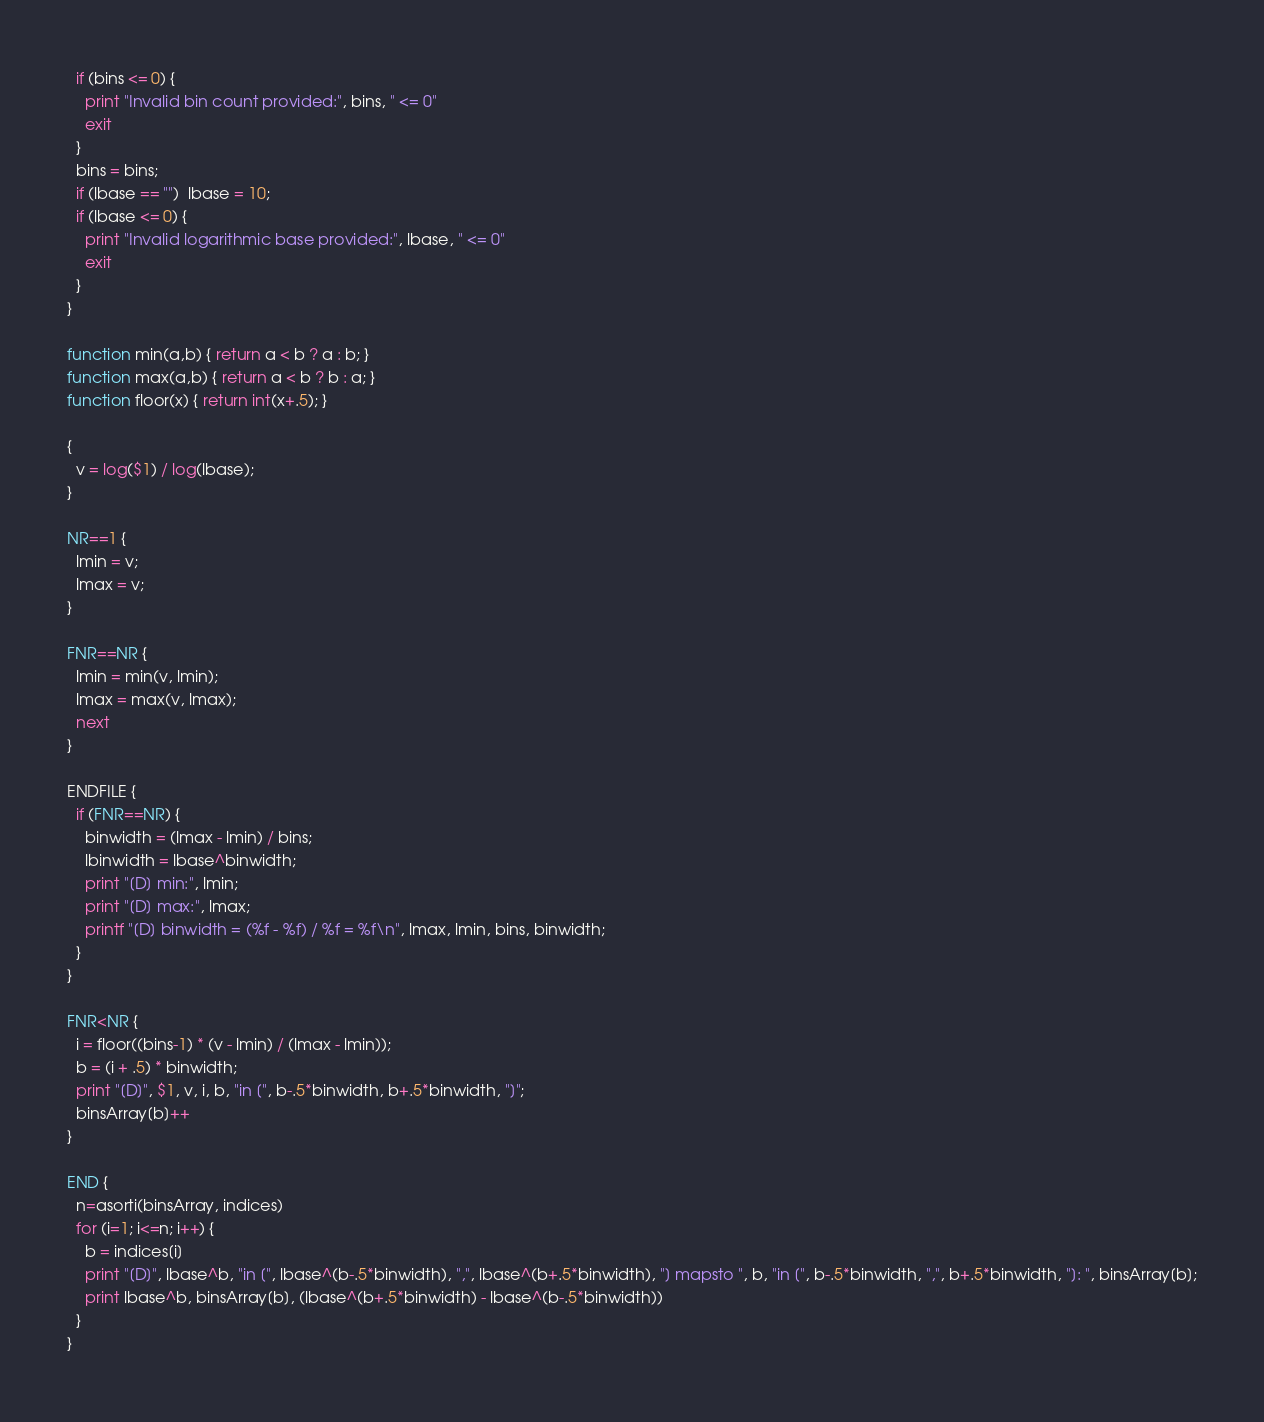Convert code to text. <code><loc_0><loc_0><loc_500><loc_500><_Awk_>  if (bins <= 0) {
    print "Invalid bin count provided:", bins, " <= 0"
    exit
  }
  bins = bins;
  if (lbase == "")  lbase = 10;
  if (lbase <= 0) {
    print "Invalid logarithmic base provided:", lbase, " <= 0"
    exit
  }
}

function min(a,b) { return a < b ? a : b; }
function max(a,b) { return a < b ? b : a; }
function floor(x) { return int(x+.5); }

{
  v = log($1) / log(lbase);
}

NR==1 {
  lmin = v;
  lmax = v;
}

FNR==NR {
  lmin = min(v, lmin);
  lmax = max(v, lmax);
  next
}

ENDFILE {
  if (FNR==NR) {
    binwidth = (lmax - lmin) / bins;
    lbinwidth = lbase^binwidth;
    print "[D] min:", lmin;
    print "[D] max:", lmax;
    printf "[D] binwidth = (%f - %f) / %f = %f\n", lmax, lmin, bins, binwidth;
  }
}

FNR<NR {
  i = floor((bins-1) * (v - lmin) / (lmax - lmin));
  b = (i + .5) * binwidth;
  print "[D]", $1, v, i, b, "in [", b-.5*binwidth, b+.5*binwidth, "]";
  binsArray[b]++
}

END {
  n=asorti(binsArray, indices)
  for (i=1; i<=n; i++) {
    b = indices[i]
    print "[D]", lbase^b, "in [", lbase^(b-.5*binwidth), ",", lbase^(b+.5*binwidth), "] mapsto ", b, "in [", b-.5*binwidth, ",", b+.5*binwidth, "]: ", binsArray[b];
    print lbase^b, binsArray[b], (lbase^(b+.5*binwidth) - lbase^(b-.5*binwidth))
  }
}
</code> 